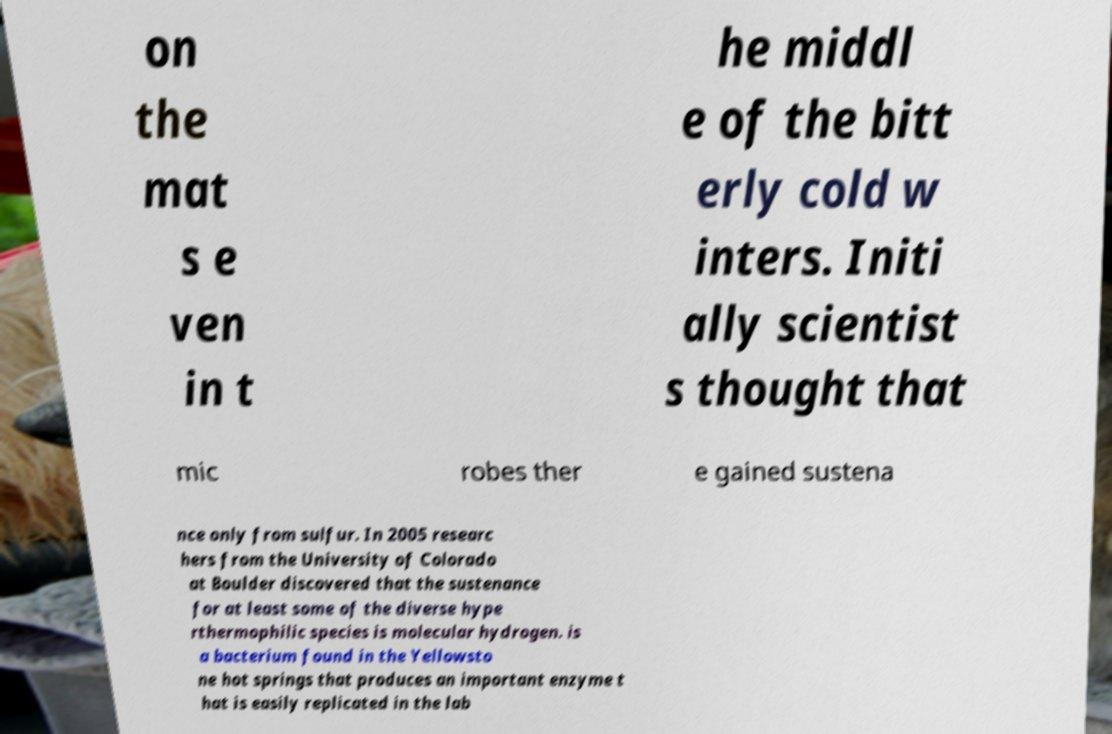Please identify and transcribe the text found in this image. on the mat s e ven in t he middl e of the bitt erly cold w inters. Initi ally scientist s thought that mic robes ther e gained sustena nce only from sulfur. In 2005 researc hers from the University of Colorado at Boulder discovered that the sustenance for at least some of the diverse hype rthermophilic species is molecular hydrogen. is a bacterium found in the Yellowsto ne hot springs that produces an important enzyme t hat is easily replicated in the lab 